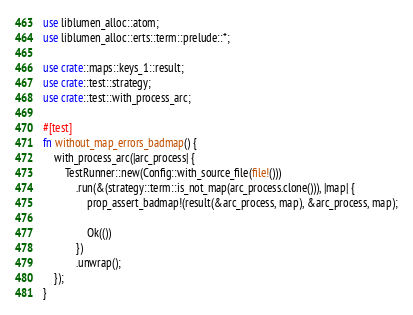<code> <loc_0><loc_0><loc_500><loc_500><_Rust_>
use liblumen_alloc::atom;
use liblumen_alloc::erts::term::prelude::*;

use crate::maps::keys_1::result;
use crate::test::strategy;
use crate::test::with_process_arc;

#[test]
fn without_map_errors_badmap() {
    with_process_arc(|arc_process| {
        TestRunner::new(Config::with_source_file(file!()))
            .run(&(strategy::term::is_not_map(arc_process.clone())), |map| {
                prop_assert_badmap!(result(&arc_process, map), &arc_process, map);

                Ok(())
            })
            .unwrap();
    });
}
</code> 